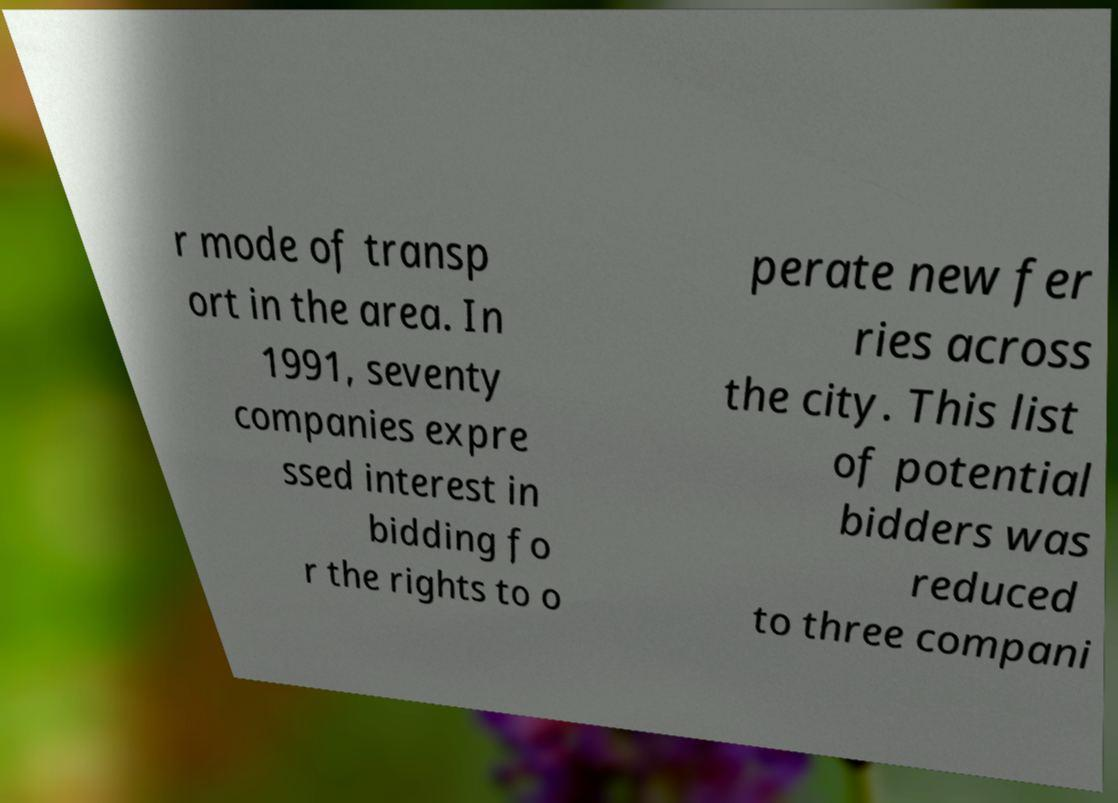For documentation purposes, I need the text within this image transcribed. Could you provide that? r mode of transp ort in the area. In 1991, seventy companies expre ssed interest in bidding fo r the rights to o perate new fer ries across the city. This list of potential bidders was reduced to three compani 